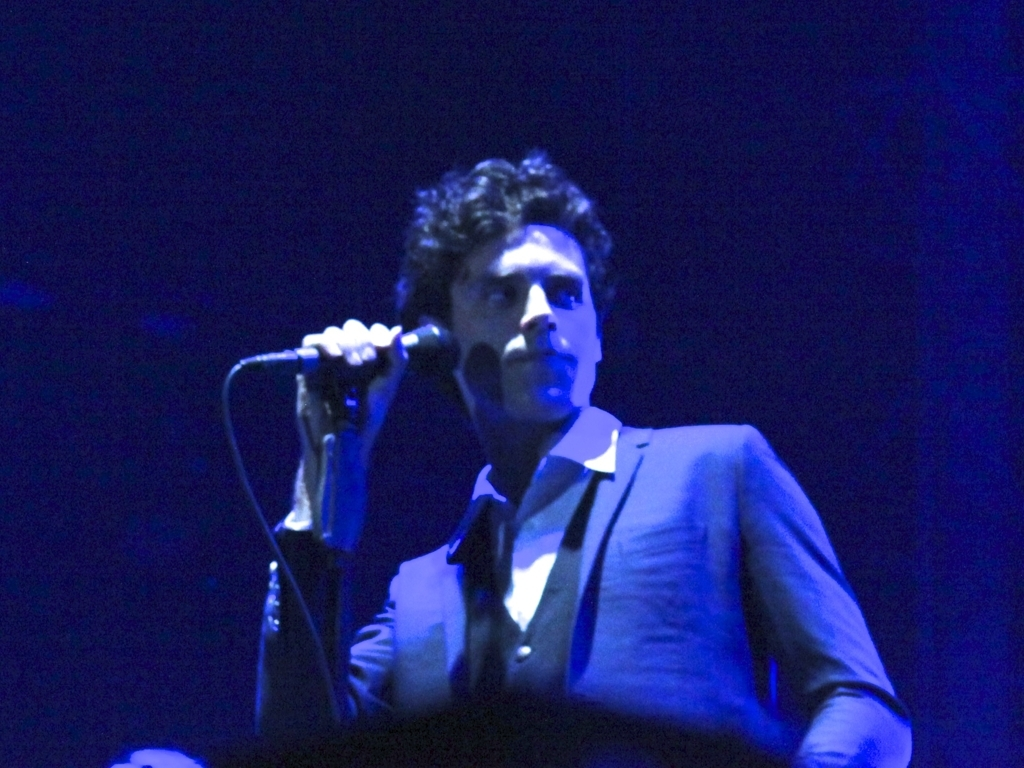Is there insufficient lighting in the image? It appears that the image captures a scene with atmospheric mood lighting, commonly used in performances or artistic settings to focus attention on the subject, which suggests that the lighting is intentionally dim. 